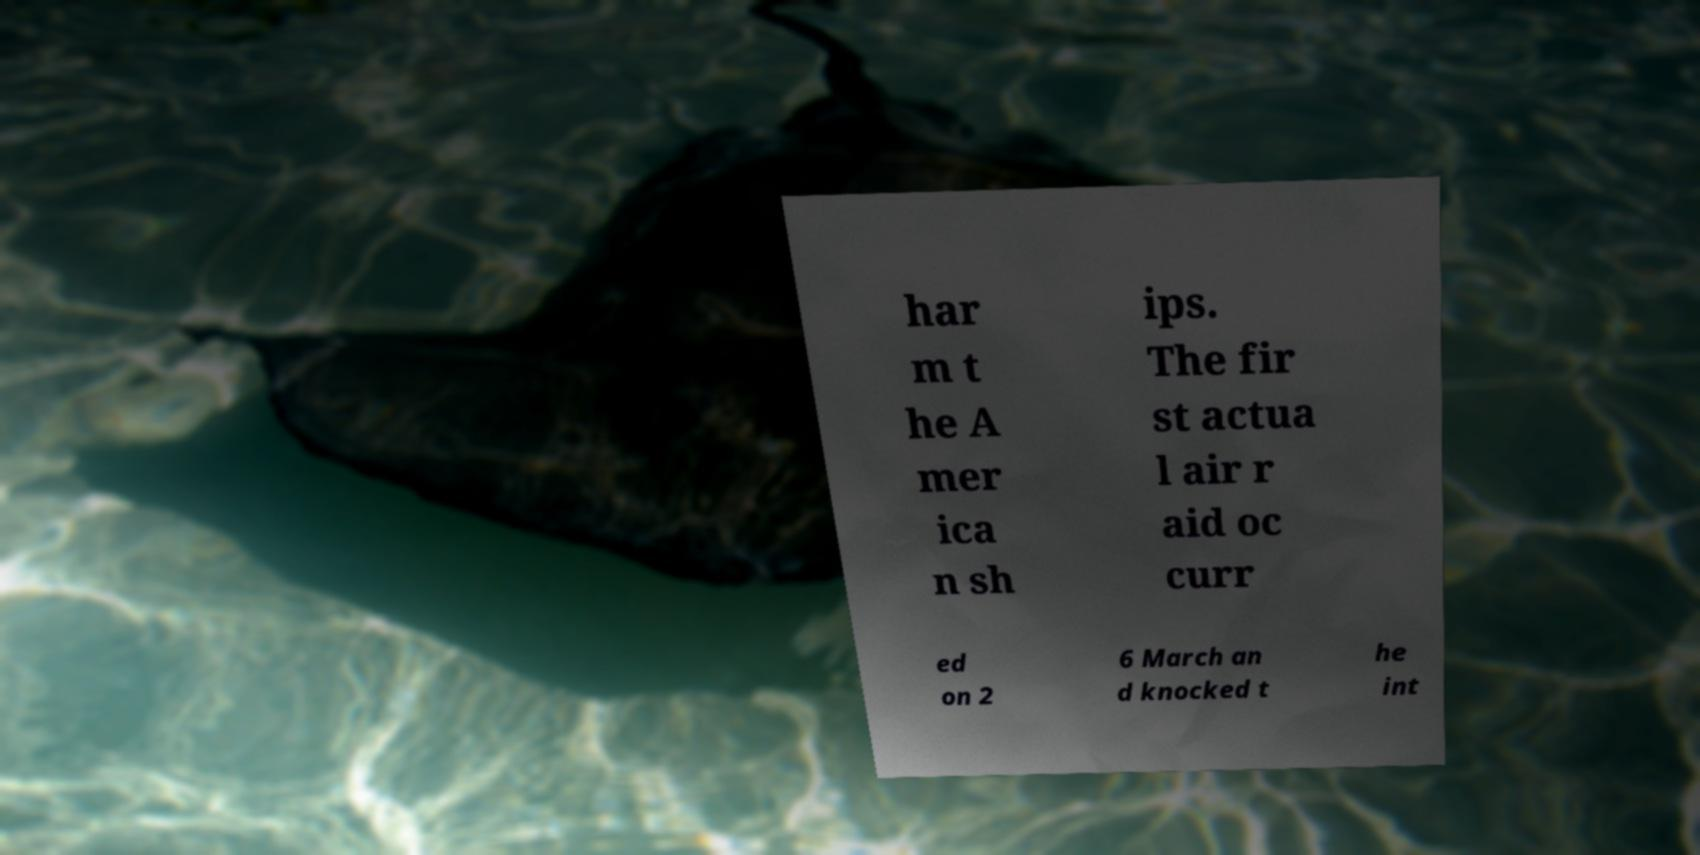I need the written content from this picture converted into text. Can you do that? har m t he A mer ica n sh ips. The fir st actua l air r aid oc curr ed on 2 6 March an d knocked t he int 